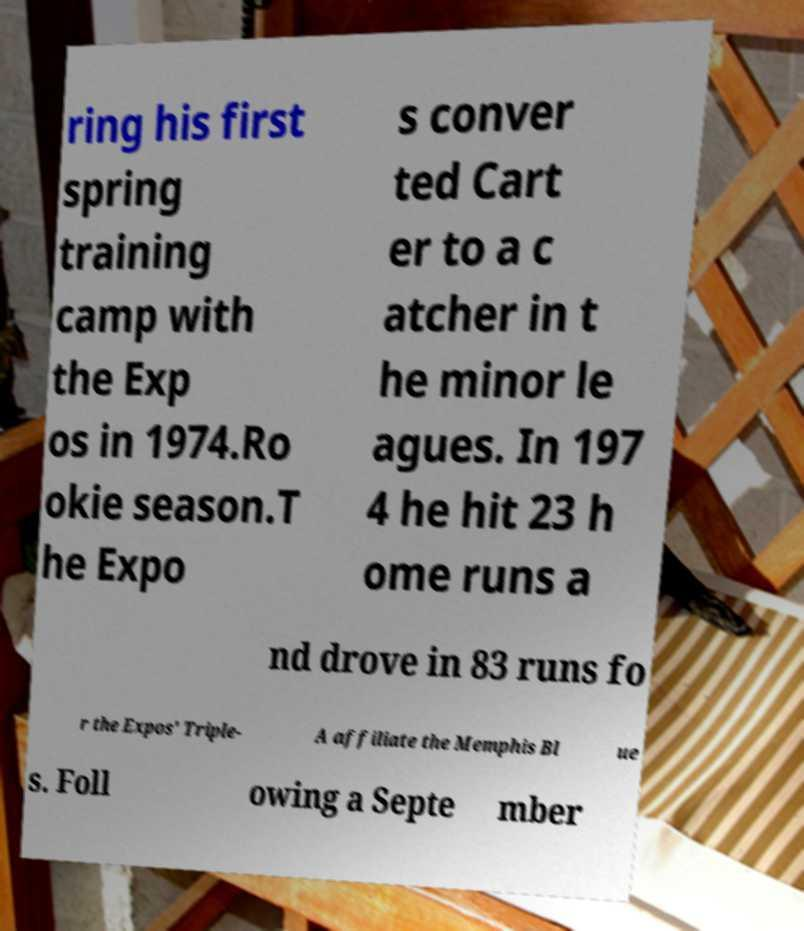Can you accurately transcribe the text from the provided image for me? ring his first spring training camp with the Exp os in 1974.Ro okie season.T he Expo s conver ted Cart er to a c atcher in t he minor le agues. In 197 4 he hit 23 h ome runs a nd drove in 83 runs fo r the Expos' Triple- A affiliate the Memphis Bl ue s. Foll owing a Septe mber 